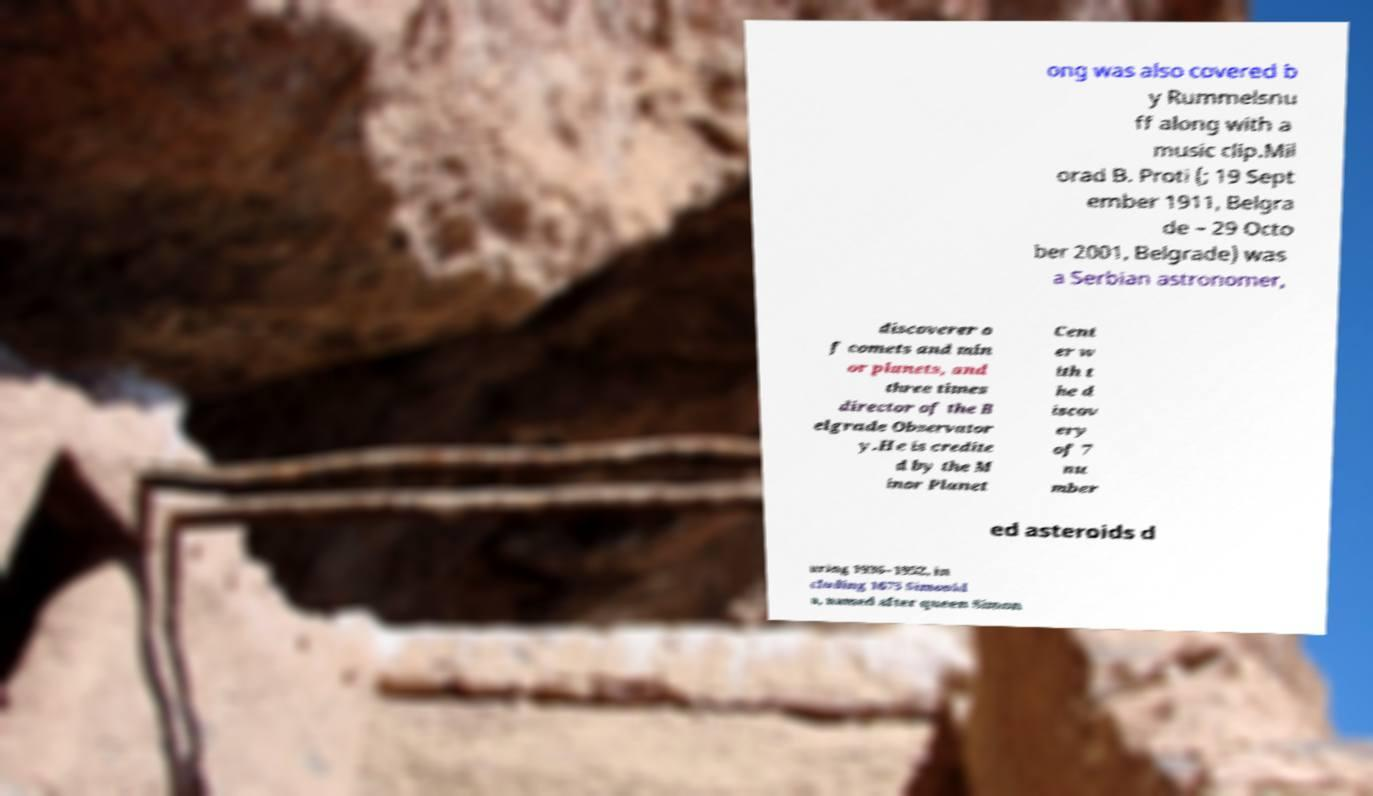Please identify and transcribe the text found in this image. ong was also covered b y Rummelsnu ff along with a music clip.Mil orad B. Proti (; 19 Sept ember 1911, Belgra de – 29 Octo ber 2001, Belgrade) was a Serbian astronomer, discoverer o f comets and min or planets, and three times director of the B elgrade Observator y.He is credite d by the M inor Planet Cent er w ith t he d iscov ery of 7 nu mber ed asteroids d uring 1936–1952, in cluding 1675 Simonid a, named after queen Simon 